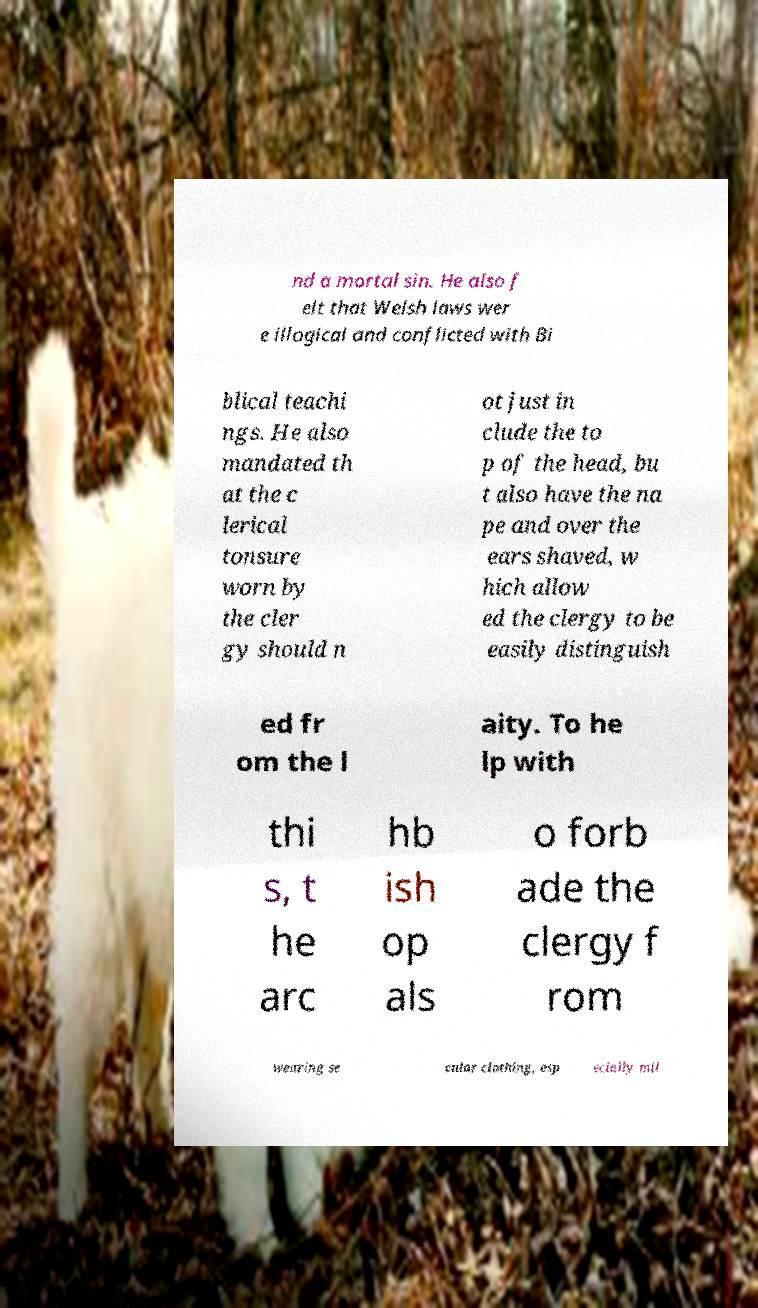Please read and relay the text visible in this image. What does it say? nd a mortal sin. He also f elt that Welsh laws wer e illogical and conflicted with Bi blical teachi ngs. He also mandated th at the c lerical tonsure worn by the cler gy should n ot just in clude the to p of the head, bu t also have the na pe and over the ears shaved, w hich allow ed the clergy to be easily distinguish ed fr om the l aity. To he lp with thi s, t he arc hb ish op als o forb ade the clergy f rom wearing se cular clothing, esp ecially mil 